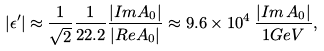<formula> <loc_0><loc_0><loc_500><loc_500>| \epsilon ^ { \prime } | \approx \frac { 1 } { \sqrt { 2 } } \frac { 1 } { 2 2 . 2 } \frac { | I m A _ { 0 } | } { | R e A _ { 0 } | } \approx 9 . 6 \times 1 0 ^ { 4 } \, \frac { | I m \, A _ { 0 } | } { 1 G e V } ,</formula> 